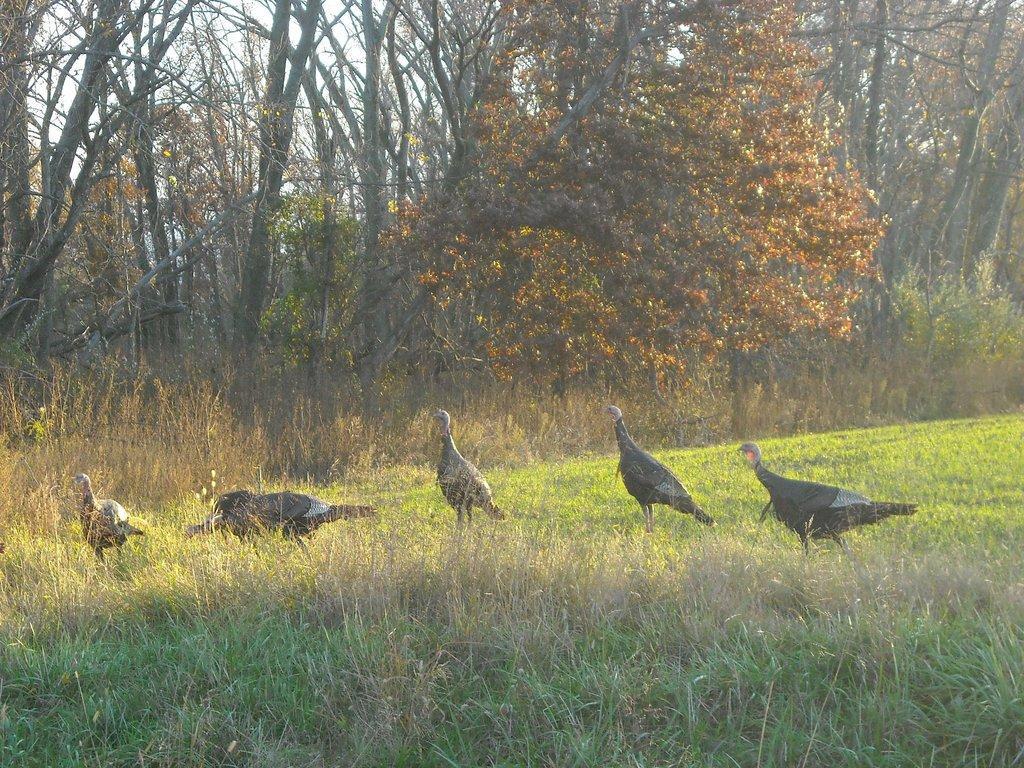Can you describe this image briefly? In this picture, we see five turkey hens. At the bottom of the picture, we see the grass. There are trees in the background. 